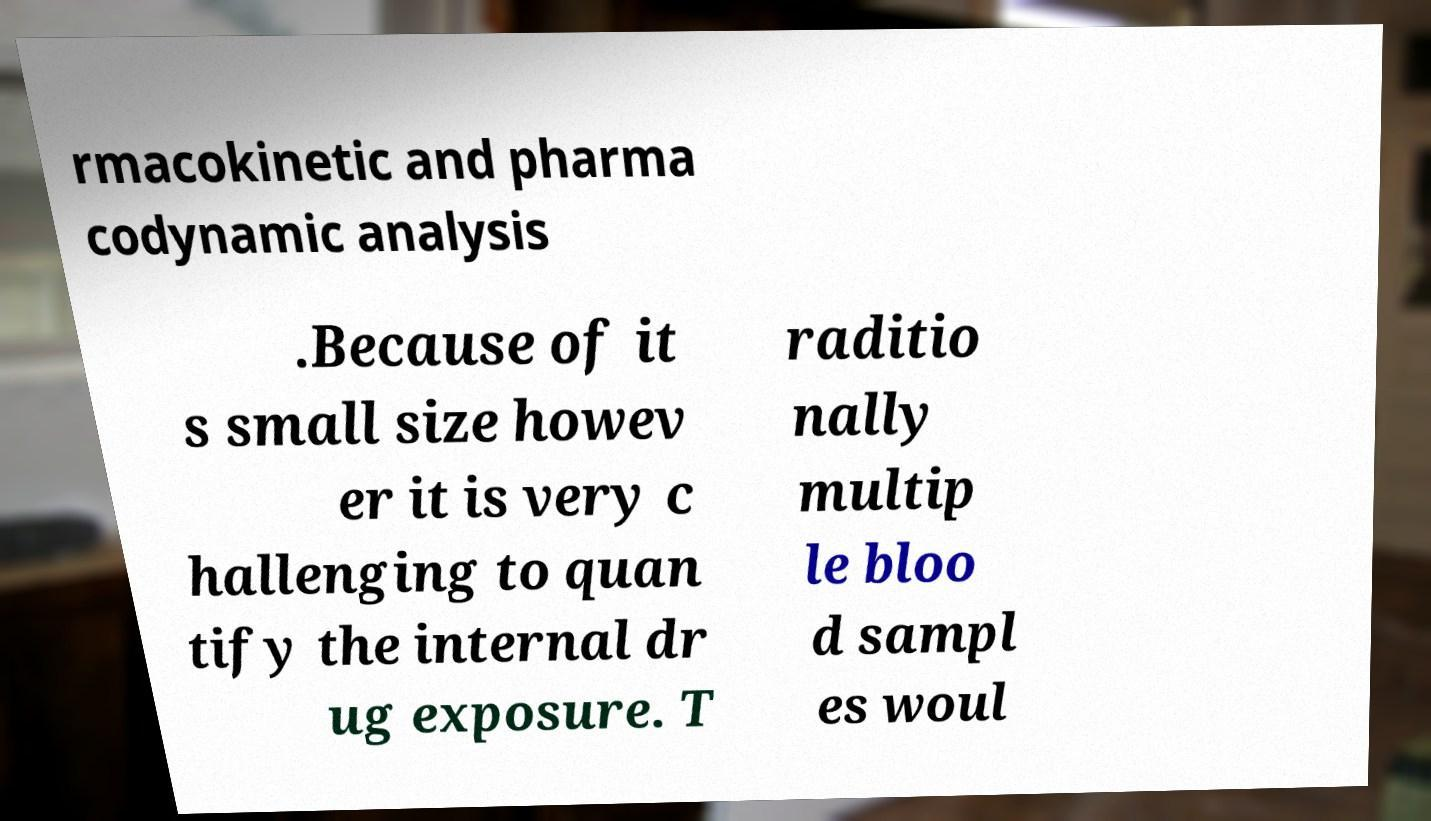Could you assist in decoding the text presented in this image and type it out clearly? rmacokinetic and pharma codynamic analysis .Because of it s small size howev er it is very c hallenging to quan tify the internal dr ug exposure. T raditio nally multip le bloo d sampl es woul 